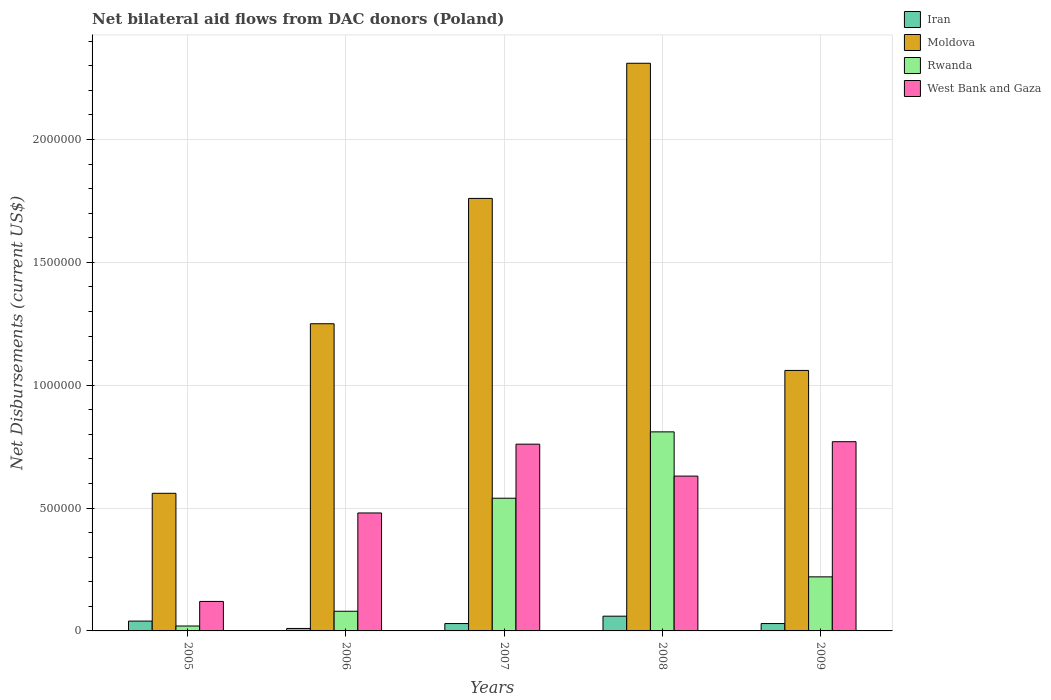How many different coloured bars are there?
Keep it short and to the point. 4. How many groups of bars are there?
Ensure brevity in your answer.  5. Are the number of bars on each tick of the X-axis equal?
Offer a very short reply. Yes. How many bars are there on the 5th tick from the left?
Offer a terse response. 4. In how many cases, is the number of bars for a given year not equal to the number of legend labels?
Your answer should be compact. 0. What is the net bilateral aid flows in West Bank and Gaza in 2005?
Give a very brief answer. 1.20e+05. Across all years, what is the maximum net bilateral aid flows in Rwanda?
Your response must be concise. 8.10e+05. Across all years, what is the minimum net bilateral aid flows in West Bank and Gaza?
Provide a succinct answer. 1.20e+05. In which year was the net bilateral aid flows in West Bank and Gaza minimum?
Your answer should be very brief. 2005. What is the total net bilateral aid flows in Rwanda in the graph?
Give a very brief answer. 1.67e+06. What is the difference between the net bilateral aid flows in Rwanda in 2006 and that in 2009?
Make the answer very short. -1.40e+05. What is the difference between the net bilateral aid flows in Iran in 2009 and the net bilateral aid flows in Rwanda in 2006?
Your answer should be compact. -5.00e+04. What is the average net bilateral aid flows in Rwanda per year?
Your answer should be very brief. 3.34e+05. In the year 2007, what is the difference between the net bilateral aid flows in Iran and net bilateral aid flows in Rwanda?
Your answer should be very brief. -5.10e+05. In how many years, is the net bilateral aid flows in Rwanda greater than 500000 US$?
Give a very brief answer. 2. What is the ratio of the net bilateral aid flows in Moldova in 2005 to that in 2008?
Your answer should be very brief. 0.24. Is the net bilateral aid flows in Moldova in 2006 less than that in 2007?
Offer a terse response. Yes. Is the difference between the net bilateral aid flows in Iran in 2006 and 2008 greater than the difference between the net bilateral aid flows in Rwanda in 2006 and 2008?
Offer a very short reply. Yes. What is the difference between the highest and the lowest net bilateral aid flows in Moldova?
Give a very brief answer. 1.75e+06. In how many years, is the net bilateral aid flows in Moldova greater than the average net bilateral aid flows in Moldova taken over all years?
Your answer should be compact. 2. Is the sum of the net bilateral aid flows in West Bank and Gaza in 2006 and 2008 greater than the maximum net bilateral aid flows in Moldova across all years?
Keep it short and to the point. No. What does the 1st bar from the left in 2009 represents?
Your answer should be compact. Iran. What does the 4th bar from the right in 2008 represents?
Provide a succinct answer. Iran. Are all the bars in the graph horizontal?
Provide a succinct answer. No. How many years are there in the graph?
Ensure brevity in your answer.  5. Does the graph contain grids?
Make the answer very short. Yes. How many legend labels are there?
Your answer should be very brief. 4. What is the title of the graph?
Your response must be concise. Net bilateral aid flows from DAC donors (Poland). What is the label or title of the Y-axis?
Your answer should be very brief. Net Disbursements (current US$). What is the Net Disbursements (current US$) of Moldova in 2005?
Provide a succinct answer. 5.60e+05. What is the Net Disbursements (current US$) of Iran in 2006?
Provide a succinct answer. 10000. What is the Net Disbursements (current US$) in Moldova in 2006?
Offer a terse response. 1.25e+06. What is the Net Disbursements (current US$) in Rwanda in 2006?
Make the answer very short. 8.00e+04. What is the Net Disbursements (current US$) of Moldova in 2007?
Your answer should be compact. 1.76e+06. What is the Net Disbursements (current US$) in Rwanda in 2007?
Your answer should be compact. 5.40e+05. What is the Net Disbursements (current US$) in West Bank and Gaza in 2007?
Offer a terse response. 7.60e+05. What is the Net Disbursements (current US$) of Moldova in 2008?
Your response must be concise. 2.31e+06. What is the Net Disbursements (current US$) of Rwanda in 2008?
Give a very brief answer. 8.10e+05. What is the Net Disbursements (current US$) of West Bank and Gaza in 2008?
Your response must be concise. 6.30e+05. What is the Net Disbursements (current US$) in Iran in 2009?
Your answer should be compact. 3.00e+04. What is the Net Disbursements (current US$) of Moldova in 2009?
Ensure brevity in your answer.  1.06e+06. What is the Net Disbursements (current US$) of West Bank and Gaza in 2009?
Provide a short and direct response. 7.70e+05. Across all years, what is the maximum Net Disbursements (current US$) in Moldova?
Provide a succinct answer. 2.31e+06. Across all years, what is the maximum Net Disbursements (current US$) in Rwanda?
Keep it short and to the point. 8.10e+05. Across all years, what is the maximum Net Disbursements (current US$) in West Bank and Gaza?
Ensure brevity in your answer.  7.70e+05. Across all years, what is the minimum Net Disbursements (current US$) in Moldova?
Provide a short and direct response. 5.60e+05. Across all years, what is the minimum Net Disbursements (current US$) in Rwanda?
Your response must be concise. 2.00e+04. Across all years, what is the minimum Net Disbursements (current US$) of West Bank and Gaza?
Keep it short and to the point. 1.20e+05. What is the total Net Disbursements (current US$) in Moldova in the graph?
Provide a succinct answer. 6.94e+06. What is the total Net Disbursements (current US$) of Rwanda in the graph?
Offer a terse response. 1.67e+06. What is the total Net Disbursements (current US$) in West Bank and Gaza in the graph?
Provide a succinct answer. 2.76e+06. What is the difference between the Net Disbursements (current US$) of Moldova in 2005 and that in 2006?
Make the answer very short. -6.90e+05. What is the difference between the Net Disbursements (current US$) in West Bank and Gaza in 2005 and that in 2006?
Provide a succinct answer. -3.60e+05. What is the difference between the Net Disbursements (current US$) of Iran in 2005 and that in 2007?
Provide a succinct answer. 10000. What is the difference between the Net Disbursements (current US$) in Moldova in 2005 and that in 2007?
Your answer should be compact. -1.20e+06. What is the difference between the Net Disbursements (current US$) in Rwanda in 2005 and that in 2007?
Offer a very short reply. -5.20e+05. What is the difference between the Net Disbursements (current US$) in West Bank and Gaza in 2005 and that in 2007?
Offer a terse response. -6.40e+05. What is the difference between the Net Disbursements (current US$) in Iran in 2005 and that in 2008?
Your answer should be very brief. -2.00e+04. What is the difference between the Net Disbursements (current US$) in Moldova in 2005 and that in 2008?
Make the answer very short. -1.75e+06. What is the difference between the Net Disbursements (current US$) in Rwanda in 2005 and that in 2008?
Offer a terse response. -7.90e+05. What is the difference between the Net Disbursements (current US$) in West Bank and Gaza in 2005 and that in 2008?
Your answer should be compact. -5.10e+05. What is the difference between the Net Disbursements (current US$) in Iran in 2005 and that in 2009?
Your answer should be very brief. 10000. What is the difference between the Net Disbursements (current US$) in Moldova in 2005 and that in 2009?
Provide a succinct answer. -5.00e+05. What is the difference between the Net Disbursements (current US$) of Rwanda in 2005 and that in 2009?
Provide a succinct answer. -2.00e+05. What is the difference between the Net Disbursements (current US$) in West Bank and Gaza in 2005 and that in 2009?
Give a very brief answer. -6.50e+05. What is the difference between the Net Disbursements (current US$) of Moldova in 2006 and that in 2007?
Keep it short and to the point. -5.10e+05. What is the difference between the Net Disbursements (current US$) in Rwanda in 2006 and that in 2007?
Offer a very short reply. -4.60e+05. What is the difference between the Net Disbursements (current US$) in West Bank and Gaza in 2006 and that in 2007?
Your response must be concise. -2.80e+05. What is the difference between the Net Disbursements (current US$) of Moldova in 2006 and that in 2008?
Offer a very short reply. -1.06e+06. What is the difference between the Net Disbursements (current US$) of Rwanda in 2006 and that in 2008?
Your answer should be compact. -7.30e+05. What is the difference between the Net Disbursements (current US$) in Moldova in 2006 and that in 2009?
Give a very brief answer. 1.90e+05. What is the difference between the Net Disbursements (current US$) in Rwanda in 2006 and that in 2009?
Keep it short and to the point. -1.40e+05. What is the difference between the Net Disbursements (current US$) in West Bank and Gaza in 2006 and that in 2009?
Your response must be concise. -2.90e+05. What is the difference between the Net Disbursements (current US$) in Iran in 2007 and that in 2008?
Provide a succinct answer. -3.00e+04. What is the difference between the Net Disbursements (current US$) in Moldova in 2007 and that in 2008?
Ensure brevity in your answer.  -5.50e+05. What is the difference between the Net Disbursements (current US$) in Rwanda in 2007 and that in 2008?
Provide a short and direct response. -2.70e+05. What is the difference between the Net Disbursements (current US$) of Iran in 2007 and that in 2009?
Make the answer very short. 0. What is the difference between the Net Disbursements (current US$) in Moldova in 2007 and that in 2009?
Provide a succinct answer. 7.00e+05. What is the difference between the Net Disbursements (current US$) in Iran in 2008 and that in 2009?
Give a very brief answer. 3.00e+04. What is the difference between the Net Disbursements (current US$) of Moldova in 2008 and that in 2009?
Make the answer very short. 1.25e+06. What is the difference between the Net Disbursements (current US$) of Rwanda in 2008 and that in 2009?
Keep it short and to the point. 5.90e+05. What is the difference between the Net Disbursements (current US$) in West Bank and Gaza in 2008 and that in 2009?
Your answer should be very brief. -1.40e+05. What is the difference between the Net Disbursements (current US$) in Iran in 2005 and the Net Disbursements (current US$) in Moldova in 2006?
Make the answer very short. -1.21e+06. What is the difference between the Net Disbursements (current US$) of Iran in 2005 and the Net Disbursements (current US$) of Rwanda in 2006?
Ensure brevity in your answer.  -4.00e+04. What is the difference between the Net Disbursements (current US$) of Iran in 2005 and the Net Disbursements (current US$) of West Bank and Gaza in 2006?
Keep it short and to the point. -4.40e+05. What is the difference between the Net Disbursements (current US$) of Moldova in 2005 and the Net Disbursements (current US$) of Rwanda in 2006?
Offer a terse response. 4.80e+05. What is the difference between the Net Disbursements (current US$) of Moldova in 2005 and the Net Disbursements (current US$) of West Bank and Gaza in 2006?
Your response must be concise. 8.00e+04. What is the difference between the Net Disbursements (current US$) in Rwanda in 2005 and the Net Disbursements (current US$) in West Bank and Gaza in 2006?
Your response must be concise. -4.60e+05. What is the difference between the Net Disbursements (current US$) of Iran in 2005 and the Net Disbursements (current US$) of Moldova in 2007?
Ensure brevity in your answer.  -1.72e+06. What is the difference between the Net Disbursements (current US$) of Iran in 2005 and the Net Disbursements (current US$) of Rwanda in 2007?
Keep it short and to the point. -5.00e+05. What is the difference between the Net Disbursements (current US$) of Iran in 2005 and the Net Disbursements (current US$) of West Bank and Gaza in 2007?
Keep it short and to the point. -7.20e+05. What is the difference between the Net Disbursements (current US$) in Moldova in 2005 and the Net Disbursements (current US$) in Rwanda in 2007?
Give a very brief answer. 2.00e+04. What is the difference between the Net Disbursements (current US$) of Moldova in 2005 and the Net Disbursements (current US$) of West Bank and Gaza in 2007?
Your response must be concise. -2.00e+05. What is the difference between the Net Disbursements (current US$) of Rwanda in 2005 and the Net Disbursements (current US$) of West Bank and Gaza in 2007?
Offer a very short reply. -7.40e+05. What is the difference between the Net Disbursements (current US$) in Iran in 2005 and the Net Disbursements (current US$) in Moldova in 2008?
Provide a short and direct response. -2.27e+06. What is the difference between the Net Disbursements (current US$) of Iran in 2005 and the Net Disbursements (current US$) of Rwanda in 2008?
Your answer should be very brief. -7.70e+05. What is the difference between the Net Disbursements (current US$) in Iran in 2005 and the Net Disbursements (current US$) in West Bank and Gaza in 2008?
Your response must be concise. -5.90e+05. What is the difference between the Net Disbursements (current US$) in Moldova in 2005 and the Net Disbursements (current US$) in Rwanda in 2008?
Your answer should be compact. -2.50e+05. What is the difference between the Net Disbursements (current US$) in Rwanda in 2005 and the Net Disbursements (current US$) in West Bank and Gaza in 2008?
Ensure brevity in your answer.  -6.10e+05. What is the difference between the Net Disbursements (current US$) in Iran in 2005 and the Net Disbursements (current US$) in Moldova in 2009?
Provide a succinct answer. -1.02e+06. What is the difference between the Net Disbursements (current US$) of Iran in 2005 and the Net Disbursements (current US$) of Rwanda in 2009?
Provide a short and direct response. -1.80e+05. What is the difference between the Net Disbursements (current US$) of Iran in 2005 and the Net Disbursements (current US$) of West Bank and Gaza in 2009?
Ensure brevity in your answer.  -7.30e+05. What is the difference between the Net Disbursements (current US$) of Moldova in 2005 and the Net Disbursements (current US$) of Rwanda in 2009?
Offer a terse response. 3.40e+05. What is the difference between the Net Disbursements (current US$) in Rwanda in 2005 and the Net Disbursements (current US$) in West Bank and Gaza in 2009?
Give a very brief answer. -7.50e+05. What is the difference between the Net Disbursements (current US$) in Iran in 2006 and the Net Disbursements (current US$) in Moldova in 2007?
Provide a succinct answer. -1.75e+06. What is the difference between the Net Disbursements (current US$) in Iran in 2006 and the Net Disbursements (current US$) in Rwanda in 2007?
Ensure brevity in your answer.  -5.30e+05. What is the difference between the Net Disbursements (current US$) of Iran in 2006 and the Net Disbursements (current US$) of West Bank and Gaza in 2007?
Ensure brevity in your answer.  -7.50e+05. What is the difference between the Net Disbursements (current US$) in Moldova in 2006 and the Net Disbursements (current US$) in Rwanda in 2007?
Provide a succinct answer. 7.10e+05. What is the difference between the Net Disbursements (current US$) in Moldova in 2006 and the Net Disbursements (current US$) in West Bank and Gaza in 2007?
Make the answer very short. 4.90e+05. What is the difference between the Net Disbursements (current US$) of Rwanda in 2006 and the Net Disbursements (current US$) of West Bank and Gaza in 2007?
Provide a short and direct response. -6.80e+05. What is the difference between the Net Disbursements (current US$) in Iran in 2006 and the Net Disbursements (current US$) in Moldova in 2008?
Ensure brevity in your answer.  -2.30e+06. What is the difference between the Net Disbursements (current US$) in Iran in 2006 and the Net Disbursements (current US$) in Rwanda in 2008?
Your answer should be very brief. -8.00e+05. What is the difference between the Net Disbursements (current US$) of Iran in 2006 and the Net Disbursements (current US$) of West Bank and Gaza in 2008?
Offer a very short reply. -6.20e+05. What is the difference between the Net Disbursements (current US$) in Moldova in 2006 and the Net Disbursements (current US$) in West Bank and Gaza in 2008?
Ensure brevity in your answer.  6.20e+05. What is the difference between the Net Disbursements (current US$) in Rwanda in 2006 and the Net Disbursements (current US$) in West Bank and Gaza in 2008?
Offer a very short reply. -5.50e+05. What is the difference between the Net Disbursements (current US$) of Iran in 2006 and the Net Disbursements (current US$) of Moldova in 2009?
Ensure brevity in your answer.  -1.05e+06. What is the difference between the Net Disbursements (current US$) of Iran in 2006 and the Net Disbursements (current US$) of West Bank and Gaza in 2009?
Your answer should be compact. -7.60e+05. What is the difference between the Net Disbursements (current US$) of Moldova in 2006 and the Net Disbursements (current US$) of Rwanda in 2009?
Your response must be concise. 1.03e+06. What is the difference between the Net Disbursements (current US$) in Moldova in 2006 and the Net Disbursements (current US$) in West Bank and Gaza in 2009?
Your answer should be compact. 4.80e+05. What is the difference between the Net Disbursements (current US$) of Rwanda in 2006 and the Net Disbursements (current US$) of West Bank and Gaza in 2009?
Offer a terse response. -6.90e+05. What is the difference between the Net Disbursements (current US$) in Iran in 2007 and the Net Disbursements (current US$) in Moldova in 2008?
Your response must be concise. -2.28e+06. What is the difference between the Net Disbursements (current US$) of Iran in 2007 and the Net Disbursements (current US$) of Rwanda in 2008?
Your response must be concise. -7.80e+05. What is the difference between the Net Disbursements (current US$) of Iran in 2007 and the Net Disbursements (current US$) of West Bank and Gaza in 2008?
Ensure brevity in your answer.  -6.00e+05. What is the difference between the Net Disbursements (current US$) in Moldova in 2007 and the Net Disbursements (current US$) in Rwanda in 2008?
Give a very brief answer. 9.50e+05. What is the difference between the Net Disbursements (current US$) in Moldova in 2007 and the Net Disbursements (current US$) in West Bank and Gaza in 2008?
Your answer should be compact. 1.13e+06. What is the difference between the Net Disbursements (current US$) of Rwanda in 2007 and the Net Disbursements (current US$) of West Bank and Gaza in 2008?
Offer a terse response. -9.00e+04. What is the difference between the Net Disbursements (current US$) in Iran in 2007 and the Net Disbursements (current US$) in Moldova in 2009?
Give a very brief answer. -1.03e+06. What is the difference between the Net Disbursements (current US$) in Iran in 2007 and the Net Disbursements (current US$) in West Bank and Gaza in 2009?
Your answer should be compact. -7.40e+05. What is the difference between the Net Disbursements (current US$) in Moldova in 2007 and the Net Disbursements (current US$) in Rwanda in 2009?
Keep it short and to the point. 1.54e+06. What is the difference between the Net Disbursements (current US$) of Moldova in 2007 and the Net Disbursements (current US$) of West Bank and Gaza in 2009?
Your answer should be very brief. 9.90e+05. What is the difference between the Net Disbursements (current US$) in Iran in 2008 and the Net Disbursements (current US$) in West Bank and Gaza in 2009?
Offer a very short reply. -7.10e+05. What is the difference between the Net Disbursements (current US$) in Moldova in 2008 and the Net Disbursements (current US$) in Rwanda in 2009?
Keep it short and to the point. 2.09e+06. What is the difference between the Net Disbursements (current US$) in Moldova in 2008 and the Net Disbursements (current US$) in West Bank and Gaza in 2009?
Your response must be concise. 1.54e+06. What is the difference between the Net Disbursements (current US$) of Rwanda in 2008 and the Net Disbursements (current US$) of West Bank and Gaza in 2009?
Give a very brief answer. 4.00e+04. What is the average Net Disbursements (current US$) in Iran per year?
Your response must be concise. 3.40e+04. What is the average Net Disbursements (current US$) of Moldova per year?
Make the answer very short. 1.39e+06. What is the average Net Disbursements (current US$) in Rwanda per year?
Your response must be concise. 3.34e+05. What is the average Net Disbursements (current US$) in West Bank and Gaza per year?
Give a very brief answer. 5.52e+05. In the year 2005, what is the difference between the Net Disbursements (current US$) of Iran and Net Disbursements (current US$) of Moldova?
Provide a short and direct response. -5.20e+05. In the year 2005, what is the difference between the Net Disbursements (current US$) of Iran and Net Disbursements (current US$) of Rwanda?
Provide a short and direct response. 2.00e+04. In the year 2005, what is the difference between the Net Disbursements (current US$) in Moldova and Net Disbursements (current US$) in Rwanda?
Offer a very short reply. 5.40e+05. In the year 2005, what is the difference between the Net Disbursements (current US$) in Moldova and Net Disbursements (current US$) in West Bank and Gaza?
Ensure brevity in your answer.  4.40e+05. In the year 2006, what is the difference between the Net Disbursements (current US$) of Iran and Net Disbursements (current US$) of Moldova?
Your answer should be very brief. -1.24e+06. In the year 2006, what is the difference between the Net Disbursements (current US$) of Iran and Net Disbursements (current US$) of Rwanda?
Provide a short and direct response. -7.00e+04. In the year 2006, what is the difference between the Net Disbursements (current US$) in Iran and Net Disbursements (current US$) in West Bank and Gaza?
Give a very brief answer. -4.70e+05. In the year 2006, what is the difference between the Net Disbursements (current US$) of Moldova and Net Disbursements (current US$) of Rwanda?
Your response must be concise. 1.17e+06. In the year 2006, what is the difference between the Net Disbursements (current US$) of Moldova and Net Disbursements (current US$) of West Bank and Gaza?
Provide a short and direct response. 7.70e+05. In the year 2006, what is the difference between the Net Disbursements (current US$) in Rwanda and Net Disbursements (current US$) in West Bank and Gaza?
Make the answer very short. -4.00e+05. In the year 2007, what is the difference between the Net Disbursements (current US$) in Iran and Net Disbursements (current US$) in Moldova?
Offer a very short reply. -1.73e+06. In the year 2007, what is the difference between the Net Disbursements (current US$) of Iran and Net Disbursements (current US$) of Rwanda?
Offer a very short reply. -5.10e+05. In the year 2007, what is the difference between the Net Disbursements (current US$) in Iran and Net Disbursements (current US$) in West Bank and Gaza?
Give a very brief answer. -7.30e+05. In the year 2007, what is the difference between the Net Disbursements (current US$) in Moldova and Net Disbursements (current US$) in Rwanda?
Your answer should be very brief. 1.22e+06. In the year 2007, what is the difference between the Net Disbursements (current US$) of Rwanda and Net Disbursements (current US$) of West Bank and Gaza?
Provide a short and direct response. -2.20e+05. In the year 2008, what is the difference between the Net Disbursements (current US$) of Iran and Net Disbursements (current US$) of Moldova?
Offer a terse response. -2.25e+06. In the year 2008, what is the difference between the Net Disbursements (current US$) of Iran and Net Disbursements (current US$) of Rwanda?
Give a very brief answer. -7.50e+05. In the year 2008, what is the difference between the Net Disbursements (current US$) in Iran and Net Disbursements (current US$) in West Bank and Gaza?
Your answer should be very brief. -5.70e+05. In the year 2008, what is the difference between the Net Disbursements (current US$) in Moldova and Net Disbursements (current US$) in Rwanda?
Your response must be concise. 1.50e+06. In the year 2008, what is the difference between the Net Disbursements (current US$) in Moldova and Net Disbursements (current US$) in West Bank and Gaza?
Offer a very short reply. 1.68e+06. In the year 2009, what is the difference between the Net Disbursements (current US$) of Iran and Net Disbursements (current US$) of Moldova?
Ensure brevity in your answer.  -1.03e+06. In the year 2009, what is the difference between the Net Disbursements (current US$) of Iran and Net Disbursements (current US$) of Rwanda?
Give a very brief answer. -1.90e+05. In the year 2009, what is the difference between the Net Disbursements (current US$) in Iran and Net Disbursements (current US$) in West Bank and Gaza?
Ensure brevity in your answer.  -7.40e+05. In the year 2009, what is the difference between the Net Disbursements (current US$) of Moldova and Net Disbursements (current US$) of Rwanda?
Provide a short and direct response. 8.40e+05. In the year 2009, what is the difference between the Net Disbursements (current US$) in Moldova and Net Disbursements (current US$) in West Bank and Gaza?
Ensure brevity in your answer.  2.90e+05. In the year 2009, what is the difference between the Net Disbursements (current US$) of Rwanda and Net Disbursements (current US$) of West Bank and Gaza?
Your answer should be compact. -5.50e+05. What is the ratio of the Net Disbursements (current US$) in Iran in 2005 to that in 2006?
Offer a terse response. 4. What is the ratio of the Net Disbursements (current US$) in Moldova in 2005 to that in 2006?
Keep it short and to the point. 0.45. What is the ratio of the Net Disbursements (current US$) in Moldova in 2005 to that in 2007?
Provide a succinct answer. 0.32. What is the ratio of the Net Disbursements (current US$) of Rwanda in 2005 to that in 2007?
Provide a succinct answer. 0.04. What is the ratio of the Net Disbursements (current US$) in West Bank and Gaza in 2005 to that in 2007?
Provide a succinct answer. 0.16. What is the ratio of the Net Disbursements (current US$) in Iran in 2005 to that in 2008?
Give a very brief answer. 0.67. What is the ratio of the Net Disbursements (current US$) of Moldova in 2005 to that in 2008?
Your answer should be very brief. 0.24. What is the ratio of the Net Disbursements (current US$) in Rwanda in 2005 to that in 2008?
Keep it short and to the point. 0.02. What is the ratio of the Net Disbursements (current US$) of West Bank and Gaza in 2005 to that in 2008?
Give a very brief answer. 0.19. What is the ratio of the Net Disbursements (current US$) of Iran in 2005 to that in 2009?
Provide a short and direct response. 1.33. What is the ratio of the Net Disbursements (current US$) in Moldova in 2005 to that in 2009?
Provide a succinct answer. 0.53. What is the ratio of the Net Disbursements (current US$) of Rwanda in 2005 to that in 2009?
Offer a very short reply. 0.09. What is the ratio of the Net Disbursements (current US$) in West Bank and Gaza in 2005 to that in 2009?
Keep it short and to the point. 0.16. What is the ratio of the Net Disbursements (current US$) in Iran in 2006 to that in 2007?
Your answer should be compact. 0.33. What is the ratio of the Net Disbursements (current US$) of Moldova in 2006 to that in 2007?
Make the answer very short. 0.71. What is the ratio of the Net Disbursements (current US$) in Rwanda in 2006 to that in 2007?
Keep it short and to the point. 0.15. What is the ratio of the Net Disbursements (current US$) in West Bank and Gaza in 2006 to that in 2007?
Offer a very short reply. 0.63. What is the ratio of the Net Disbursements (current US$) of Iran in 2006 to that in 2008?
Your answer should be compact. 0.17. What is the ratio of the Net Disbursements (current US$) of Moldova in 2006 to that in 2008?
Ensure brevity in your answer.  0.54. What is the ratio of the Net Disbursements (current US$) of Rwanda in 2006 to that in 2008?
Ensure brevity in your answer.  0.1. What is the ratio of the Net Disbursements (current US$) in West Bank and Gaza in 2006 to that in 2008?
Offer a terse response. 0.76. What is the ratio of the Net Disbursements (current US$) in Iran in 2006 to that in 2009?
Offer a very short reply. 0.33. What is the ratio of the Net Disbursements (current US$) in Moldova in 2006 to that in 2009?
Offer a very short reply. 1.18. What is the ratio of the Net Disbursements (current US$) of Rwanda in 2006 to that in 2009?
Provide a succinct answer. 0.36. What is the ratio of the Net Disbursements (current US$) in West Bank and Gaza in 2006 to that in 2009?
Provide a short and direct response. 0.62. What is the ratio of the Net Disbursements (current US$) of Iran in 2007 to that in 2008?
Provide a succinct answer. 0.5. What is the ratio of the Net Disbursements (current US$) of Moldova in 2007 to that in 2008?
Provide a short and direct response. 0.76. What is the ratio of the Net Disbursements (current US$) in West Bank and Gaza in 2007 to that in 2008?
Give a very brief answer. 1.21. What is the ratio of the Net Disbursements (current US$) of Iran in 2007 to that in 2009?
Provide a short and direct response. 1. What is the ratio of the Net Disbursements (current US$) in Moldova in 2007 to that in 2009?
Keep it short and to the point. 1.66. What is the ratio of the Net Disbursements (current US$) of Rwanda in 2007 to that in 2009?
Your answer should be compact. 2.45. What is the ratio of the Net Disbursements (current US$) of West Bank and Gaza in 2007 to that in 2009?
Your answer should be very brief. 0.99. What is the ratio of the Net Disbursements (current US$) of Moldova in 2008 to that in 2009?
Offer a very short reply. 2.18. What is the ratio of the Net Disbursements (current US$) of Rwanda in 2008 to that in 2009?
Give a very brief answer. 3.68. What is the ratio of the Net Disbursements (current US$) in West Bank and Gaza in 2008 to that in 2009?
Make the answer very short. 0.82. What is the difference between the highest and the second highest Net Disbursements (current US$) in Moldova?
Your answer should be compact. 5.50e+05. What is the difference between the highest and the second highest Net Disbursements (current US$) of West Bank and Gaza?
Keep it short and to the point. 10000. What is the difference between the highest and the lowest Net Disbursements (current US$) of Iran?
Your response must be concise. 5.00e+04. What is the difference between the highest and the lowest Net Disbursements (current US$) of Moldova?
Give a very brief answer. 1.75e+06. What is the difference between the highest and the lowest Net Disbursements (current US$) in Rwanda?
Provide a succinct answer. 7.90e+05. What is the difference between the highest and the lowest Net Disbursements (current US$) of West Bank and Gaza?
Offer a terse response. 6.50e+05. 